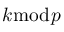<formula> <loc_0><loc_0><loc_500><loc_500>k { \bmod { p } }</formula> 